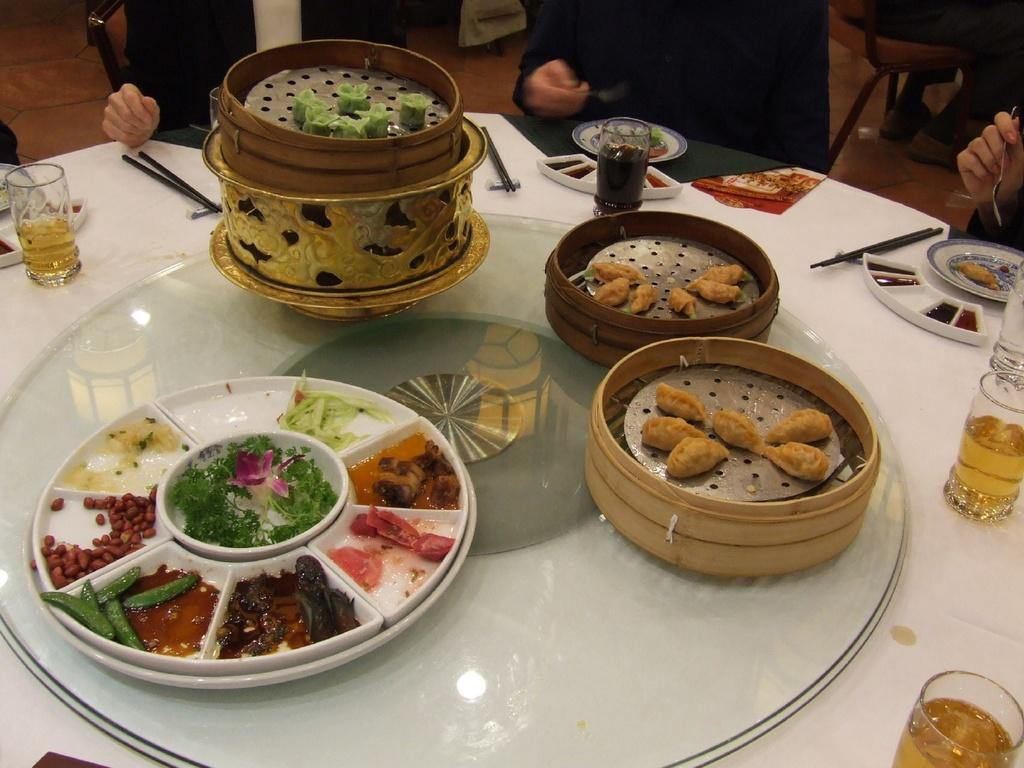What piece of furniture is present in the image? There is a table in the image. What can be found on the table? There are objects on the table, including glasses. Can you describe the people in the image? There are people sitting on chairs in the image. What type of thought can be seen in the image? There are no thoughts visible in the image; it contains a table, objects, glasses, and people sitting on chairs. How many eggs are present on the table in the image? There is no mention of eggs in the image; it only includes a table, objects, glasses, and people sitting on chairs. 